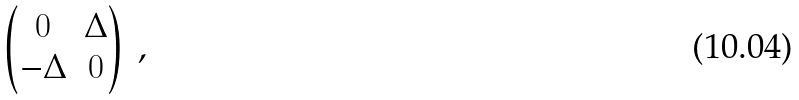Convert formula to latex. <formula><loc_0><loc_0><loc_500><loc_500>\begin{pmatrix} 0 & \Delta \\ - \Delta & 0 \end{pmatrix} \, ,</formula> 